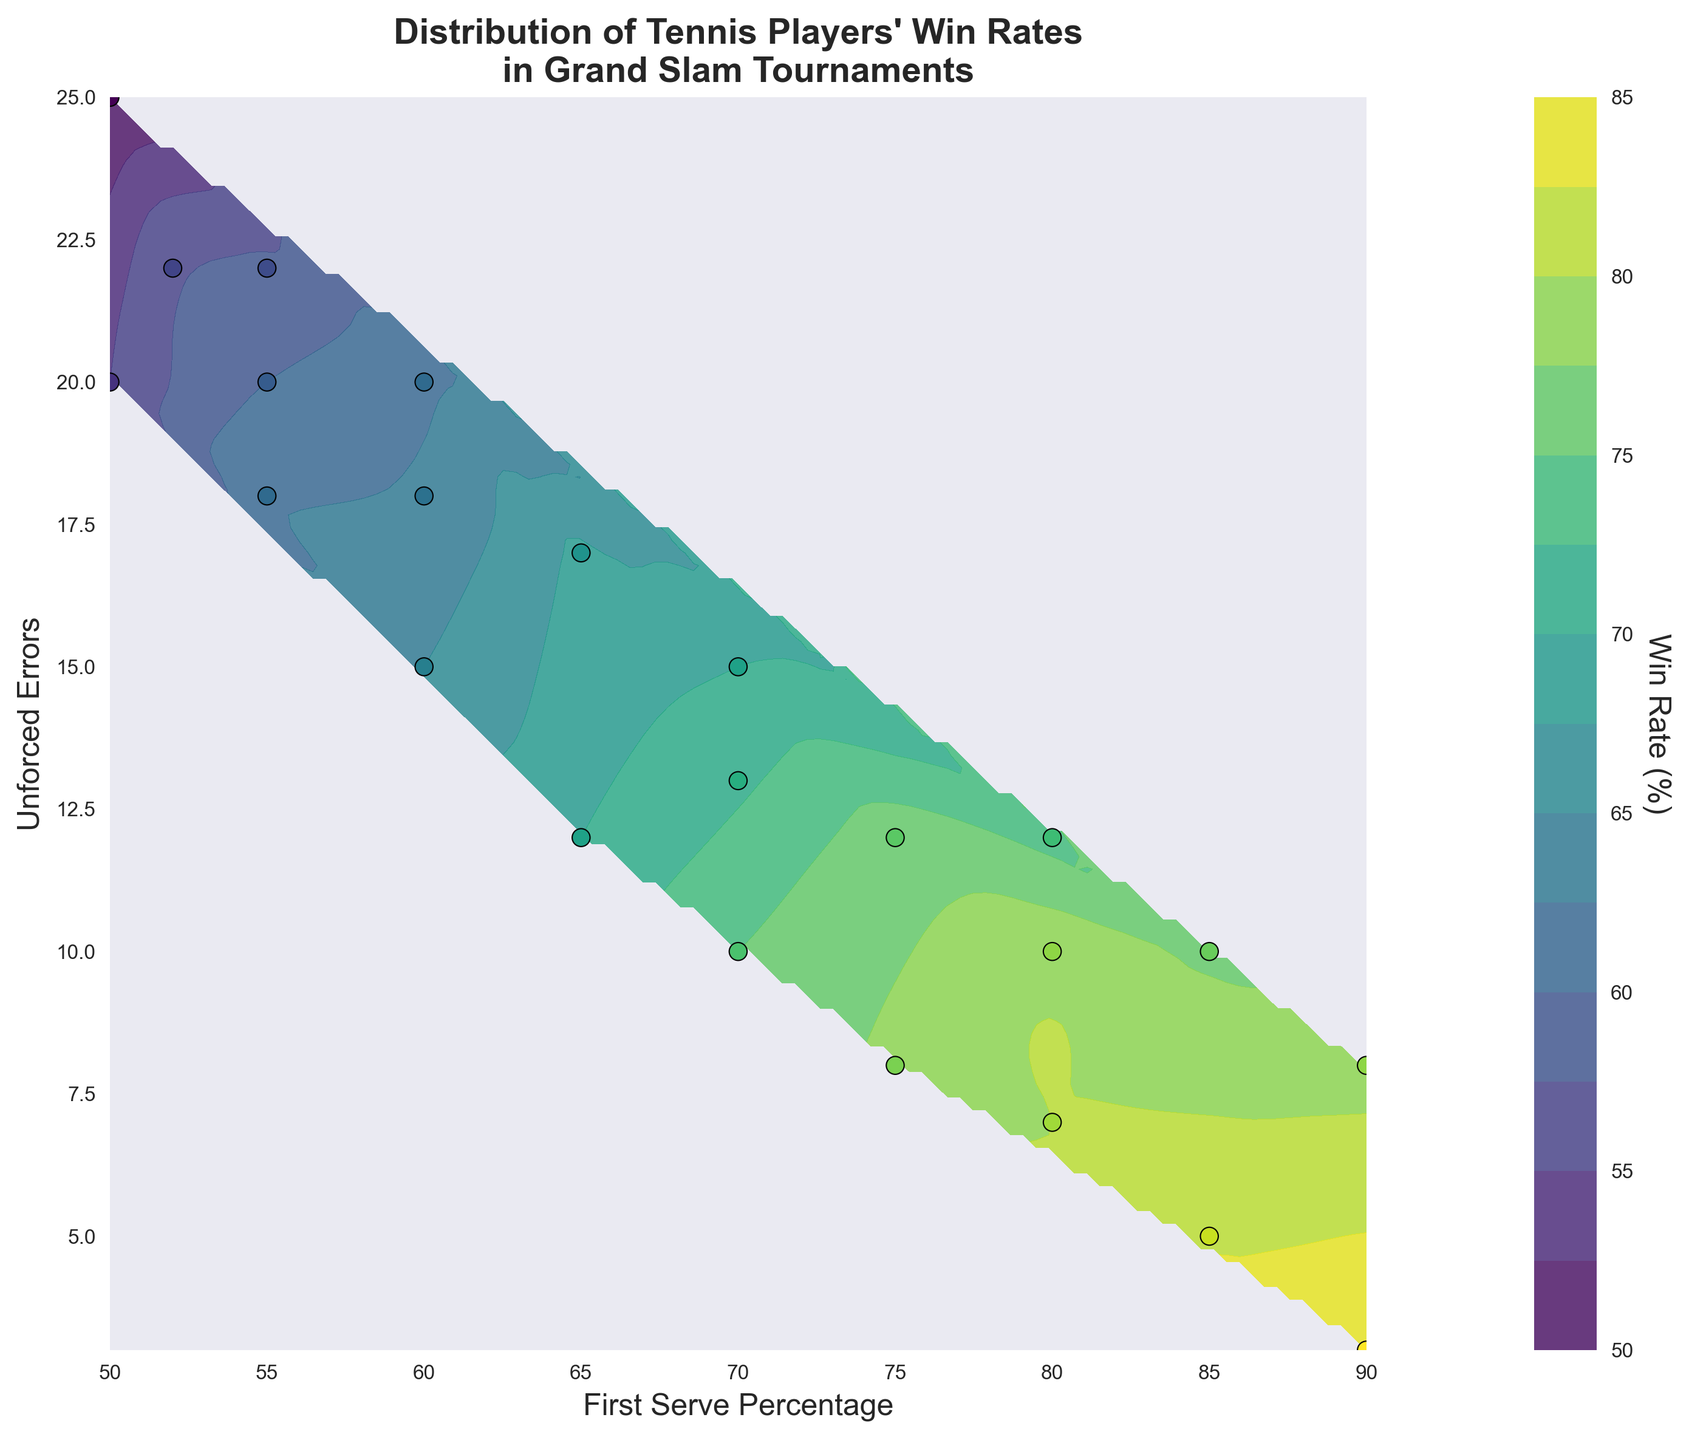What does the title of the plot indicate? The title of the plot indicates that the figure shows the distribution of tennis players' win rates in Grand Slam tournaments based on their first serve percentage and the number of unforced errors.
Answer: Distribution of Tennis Players' Win Rates in Grand Slam Tournaments What two variables are represented on the x and y axes respectively? The x-axis represents the first serve percentage, while the y-axis represents the number of unforced errors.
Answer: First Serve Percentage (x-axis) and Unforced Errors (y-axis) What color represents the highest win rate on the contour plot? The color representing the highest win rate on the contour plot is likely a bright color towards the end of the viridis color scale, such as yellow.
Answer: Yellow How many data points are visibly scattered on the plot? By counting the individual points marked on the figure, there are 20 scatter points.
Answer: 20 What is the range of the first serve percentage shown on the x-axis? The x-axis displays the first serve percentages ranging from a minimum of 50% to a maximum of 90%.
Answer: 50% to 90% Describe the trend of win rates as first serve percentage increases while keeping unforced errors constant. As the first serve percentage increases while keeping unforced errors constant, the win rate generally increases, which is indicated by the upward trend in colors on the contour levels.
Answer: Win rate increases What win rate is associated with the fewest unforced errors and highest first serve percentage? The fewest unforced errors and highest first serve percentage combination corresponds to a win rate of 85%.
Answer: 85% How does the win rate change when unforced errors increase from 10 to 25 while keeping the first serve percentage constant at 50%? By observing the contour lines, we can see that the win rate decreases significantly from around 55% to 50% when unforced errors increase from 10 to 25 at a constant first serve percentage of 50%.
Answer: Decreases Compare the win rates for a first serve percentage of 60% at 15 unforced errors and 20 unforced errors. The win rate at 60% first serve percentage with 15 unforced errors is around 65%, while for 20 unforced errors, it is approximately 62%.
Answer: 65% vs 62% What general relationship can be inferred between win rate, first serve percentage, and unforced errors based on the contour plot? The general relationship inferred from the contour plot is that higher first serve percentages and fewer unforced errors are associated with higher win rates.
Answer: Higher first serve percentages and fewer unforced errors lead to higher win rates 